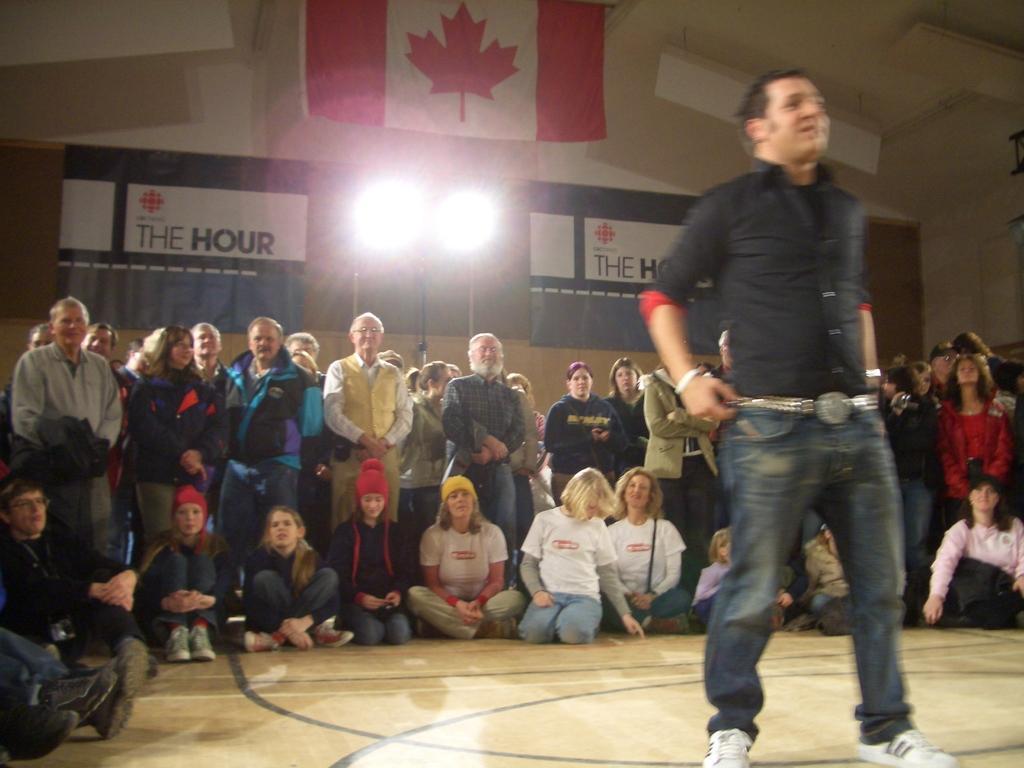How would you summarize this image in a sentence or two? In this picture I can observe a man standing on the floor on the right side. Behind him I can observe some people are sitting and some people are standing on the floor. In the background I can observe two lights and wall. 